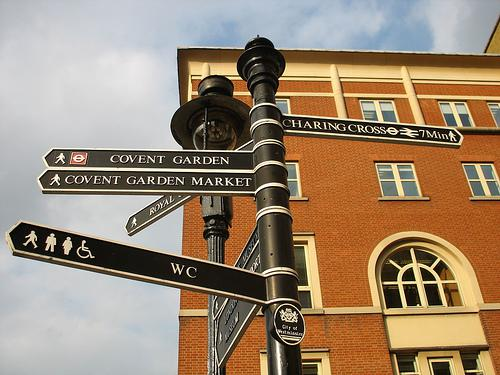Question: what is this?
Choices:
A. A spatula.
B. A street sign.
C. A fork.
D. A knife.
Answer with the letter. Answer: B Question: who reads these signs?
Choices:
A. Pedestrians.
B. Drivers.
C. Children.
D. Deaf.
Answer with the letter. Answer: A Question: when will the street lights go on?
Choices:
A. At night.
B. When you turn the switch.
C. At 8:00 pm.
D. At dusk.
Answer with the letter. Answer: D Question: where are the signs?
Choices:
A. In the street.
B. On a black pole.
C. On the wire.
D. On the building.
Answer with the letter. Answer: B 